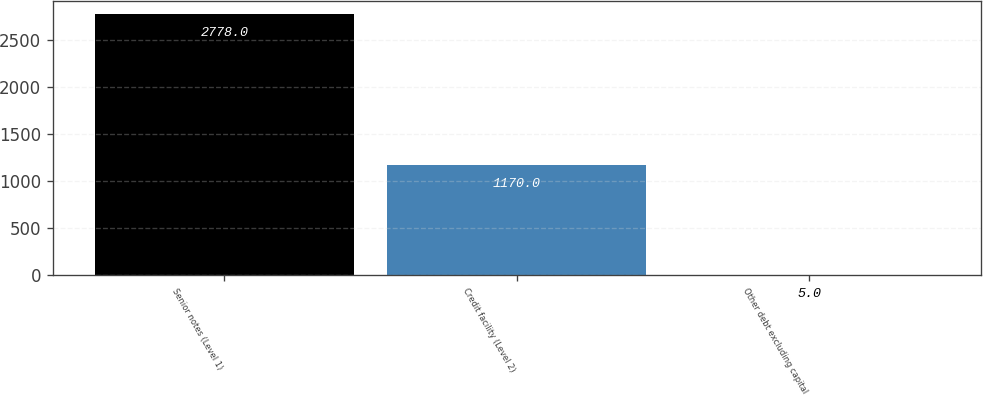Convert chart. <chart><loc_0><loc_0><loc_500><loc_500><bar_chart><fcel>Senior notes (Level 1)<fcel>Credit facility (Level 2)<fcel>Other debt excluding capital<nl><fcel>2778<fcel>1170<fcel>5<nl></chart> 